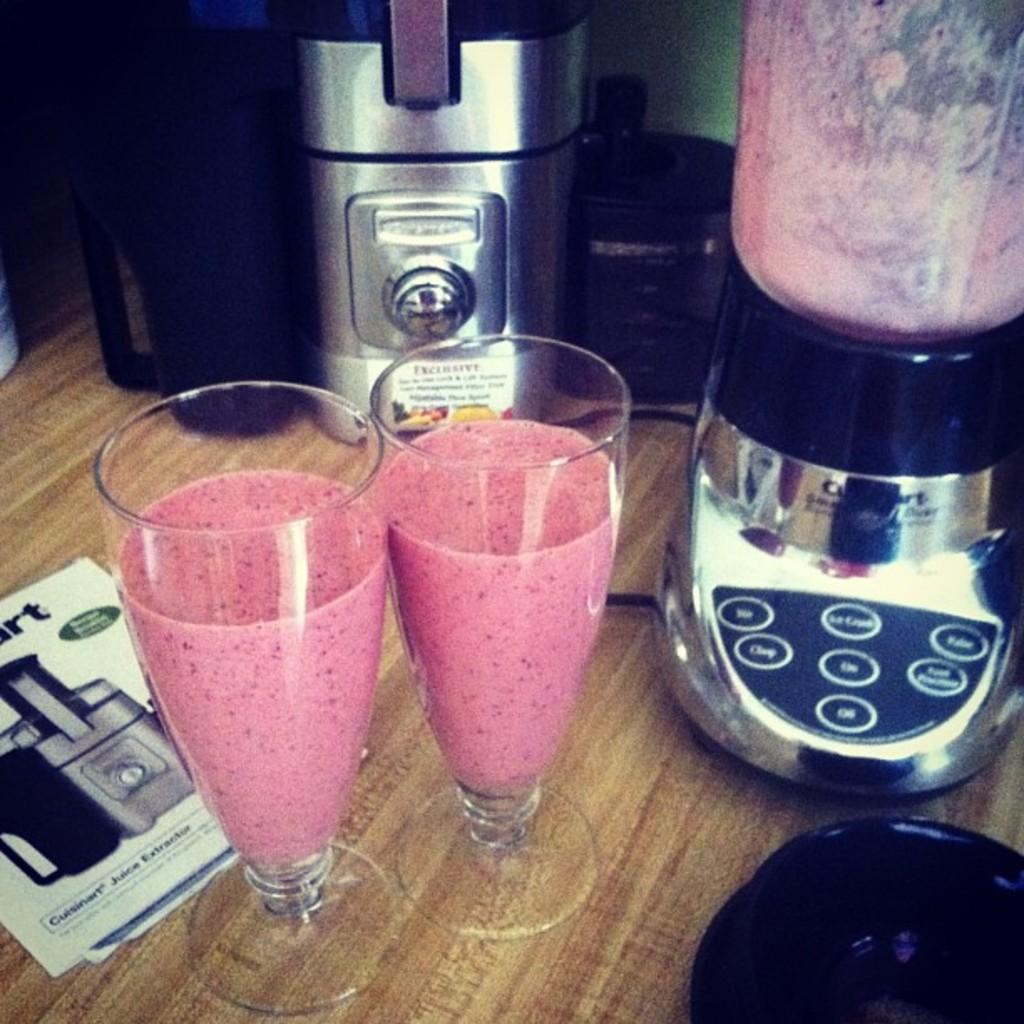What brand is the blender?
Your answer should be very brief. Cuisinart. What does the bottom setting say?
Ensure brevity in your answer.  On. 